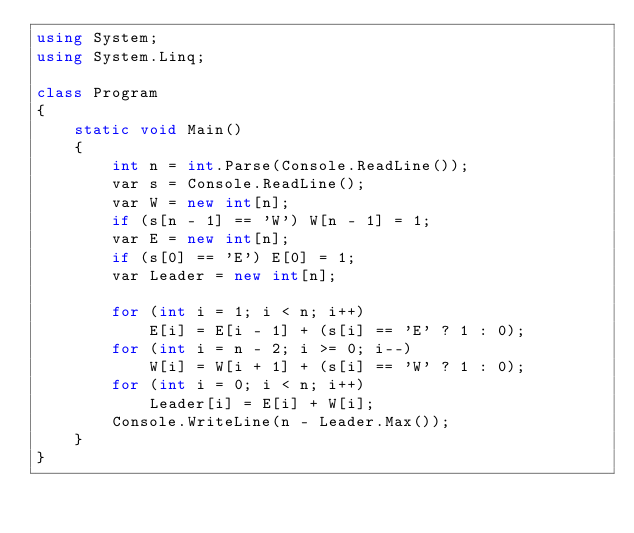<code> <loc_0><loc_0><loc_500><loc_500><_C#_>using System;
using System.Linq;

class Program
{
    static void Main()
    {
        int n = int.Parse(Console.ReadLine());
        var s = Console.ReadLine();
        var W = new int[n];
        if (s[n - 1] == 'W') W[n - 1] = 1;
        var E = new int[n];
        if (s[0] == 'E') E[0] = 1;
        var Leader = new int[n];

        for (int i = 1; i < n; i++)
            E[i] = E[i - 1] + (s[i] == 'E' ? 1 : 0);
        for (int i = n - 2; i >= 0; i--)
            W[i] = W[i + 1] + (s[i] == 'W' ? 1 : 0);
        for (int i = 0; i < n; i++)
            Leader[i] = E[i] + W[i];
        Console.WriteLine(n - Leader.Max());
    }
}
</code> 